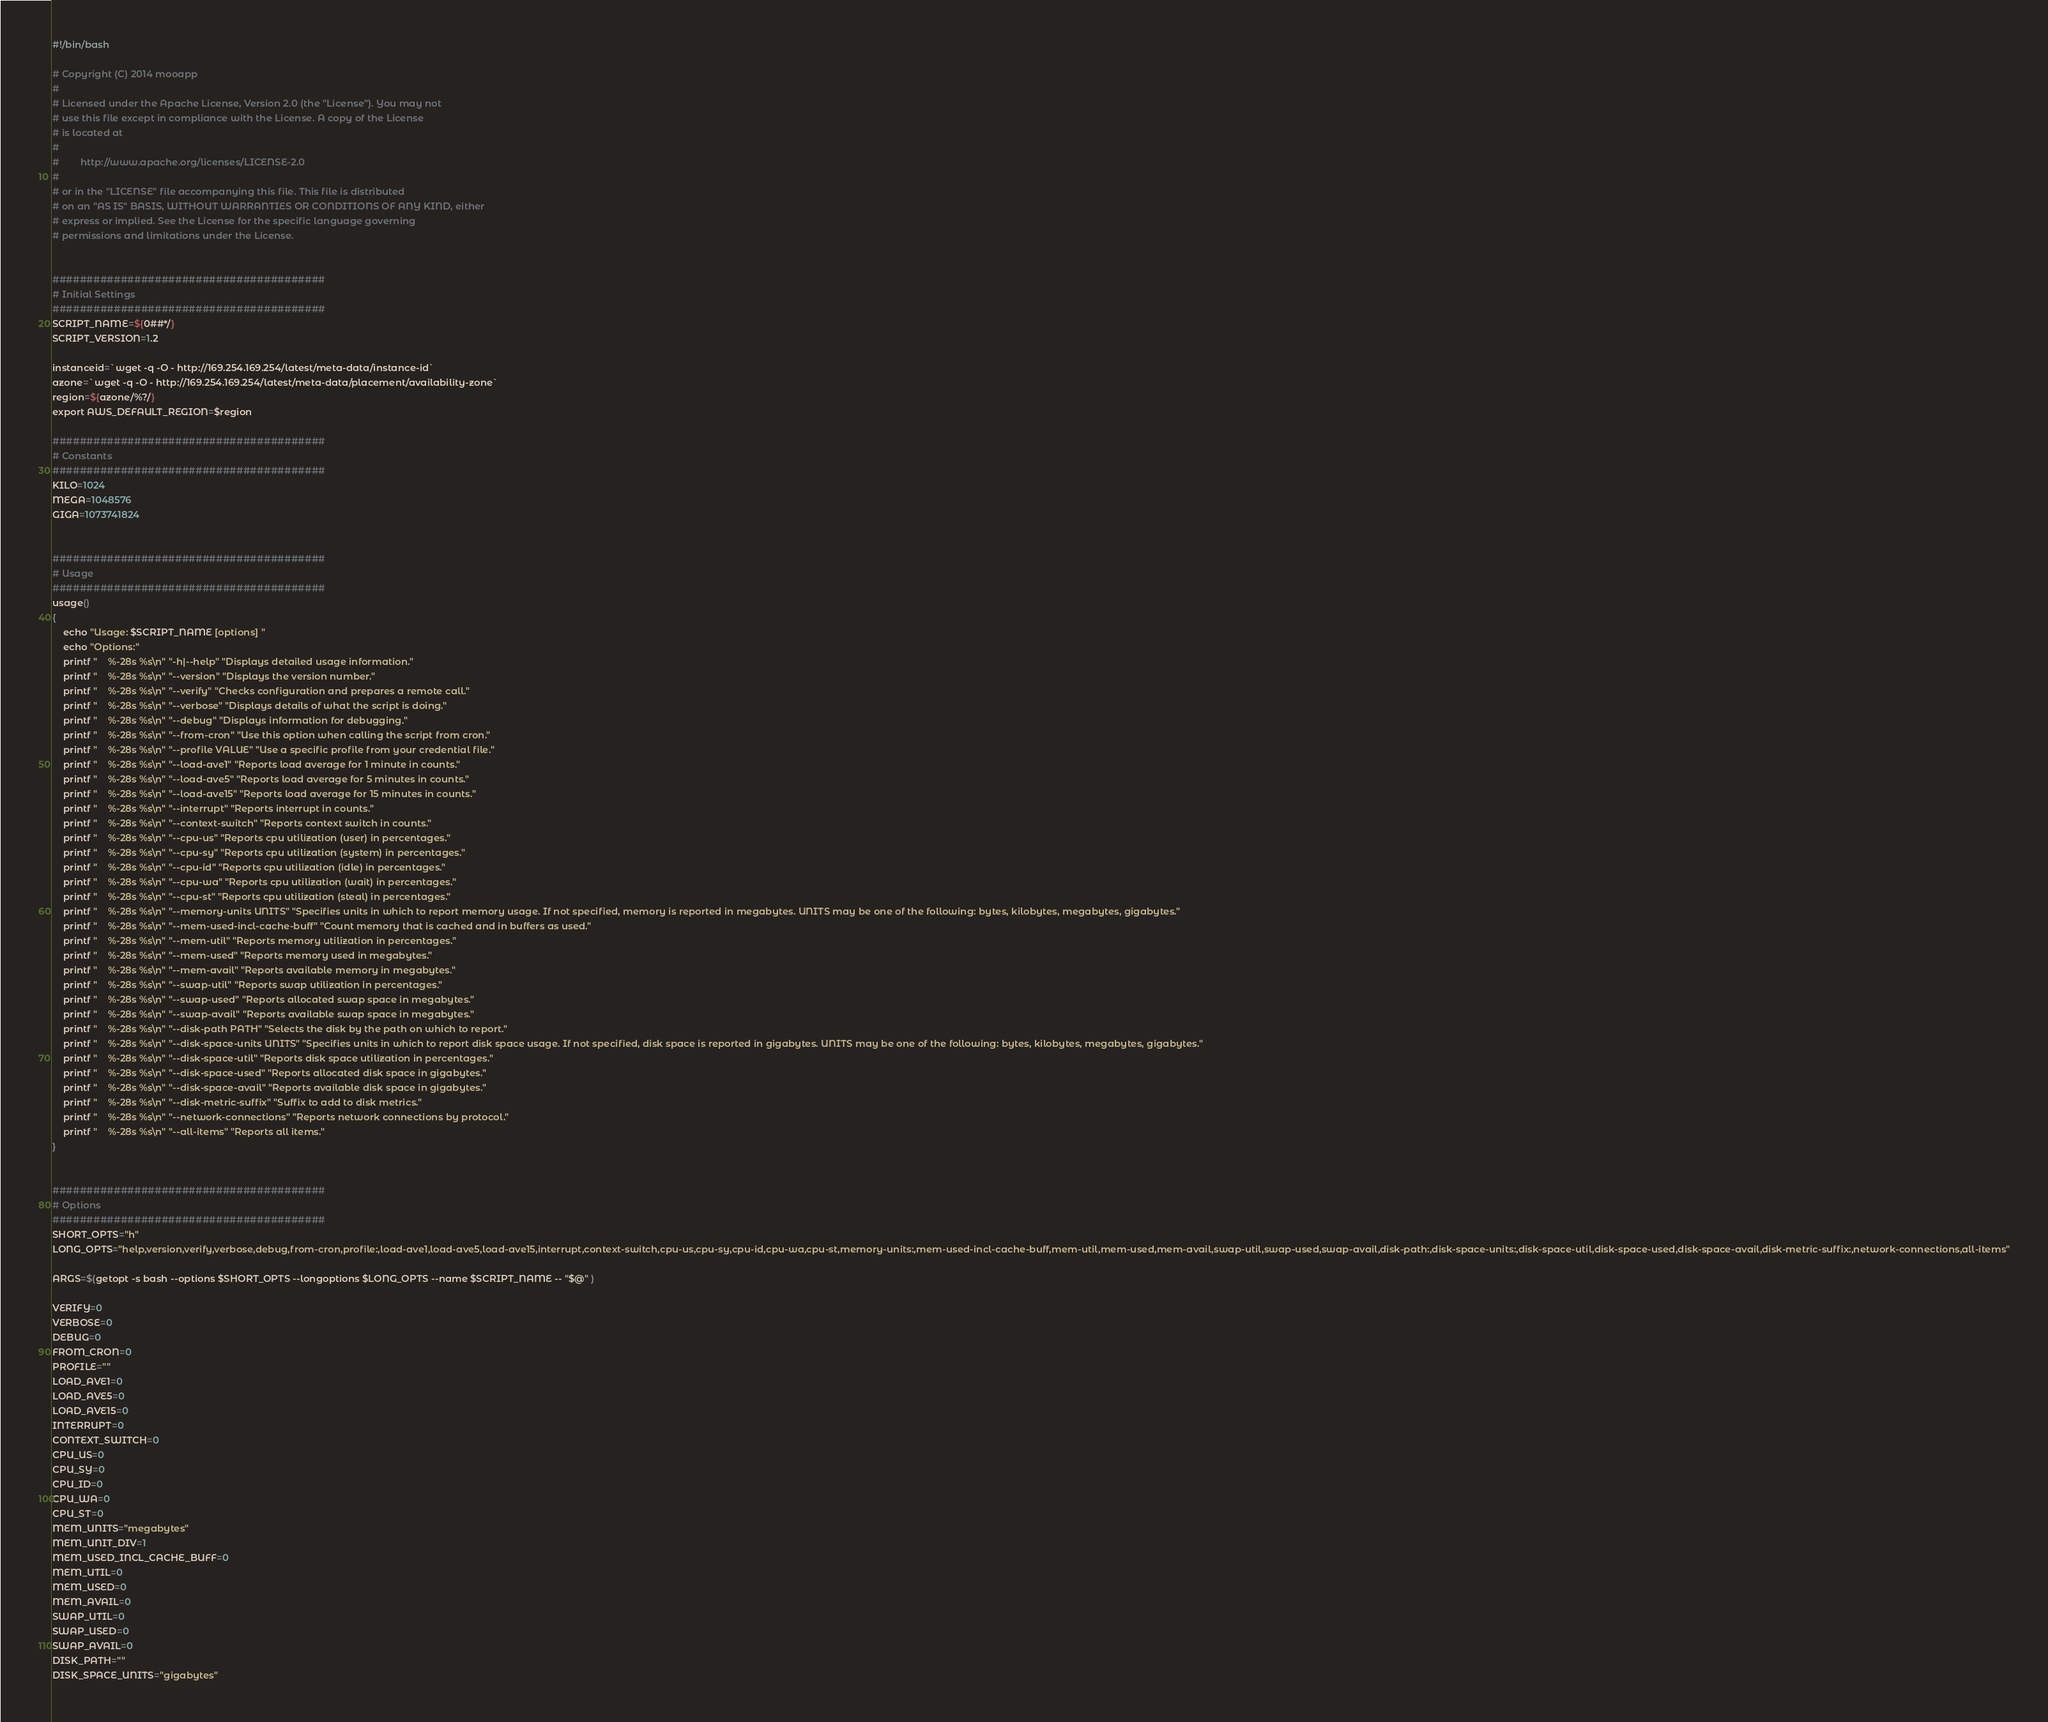Convert code to text. <code><loc_0><loc_0><loc_500><loc_500><_Bash_>#!/bin/bash

# Copyright (C) 2014 mooapp
#
# Licensed under the Apache License, Version 2.0 (the "License"). You may not
# use this file except in compliance with the License. A copy of the License
# is located at
#
#        http://www.apache.org/licenses/LICENSE-2.0
#
# or in the "LICENSE" file accompanying this file. This file is distributed
# on an "AS IS" BASIS, WITHOUT WARRANTIES OR CONDITIONS OF ANY KIND, either
# express or implied. See the License for the specific language governing
# permissions and limitations under the License.


########################################
# Initial Settings
########################################
SCRIPT_NAME=${0##*/}
SCRIPT_VERSION=1.2

instanceid=`wget -q -O - http://169.254.169.254/latest/meta-data/instance-id`
azone=`wget -q -O - http://169.254.169.254/latest/meta-data/placement/availability-zone`
region=${azone/%?/}
export AWS_DEFAULT_REGION=$region

########################################
# Constants
########################################
KILO=1024
MEGA=1048576
GIGA=1073741824


########################################
# Usage
########################################
usage()
{
    echo "Usage: $SCRIPT_NAME [options] "
    echo "Options:"
    printf "    %-28s %s\n" "-h|--help" "Displays detailed usage information."
    printf "    %-28s %s\n" "--version" "Displays the version number."
    printf "    %-28s %s\n" "--verify" "Checks configuration and prepares a remote call."
    printf "    %-28s %s\n" "--verbose" "Displays details of what the script is doing."
    printf "    %-28s %s\n" "--debug" "Displays information for debugging."
    printf "    %-28s %s\n" "--from-cron" "Use this option when calling the script from cron."
    printf "    %-28s %s\n" "--profile VALUE" "Use a specific profile from your credential file."
    printf "    %-28s %s\n" "--load-ave1" "Reports load average for 1 minute in counts."
    printf "    %-28s %s\n" "--load-ave5" "Reports load average for 5 minutes in counts."
    printf "    %-28s %s\n" "--load-ave15" "Reports load average for 15 minutes in counts."
    printf "    %-28s %s\n" "--interrupt" "Reports interrupt in counts."
    printf "    %-28s %s\n" "--context-switch" "Reports context switch in counts."
    printf "    %-28s %s\n" "--cpu-us" "Reports cpu utilization (user) in percentages."
    printf "    %-28s %s\n" "--cpu-sy" "Reports cpu utilization (system) in percentages."
    printf "    %-28s %s\n" "--cpu-id" "Reports cpu utilization (idle) in percentages."
    printf "    %-28s %s\n" "--cpu-wa" "Reports cpu utilization (wait) in percentages."
    printf "    %-28s %s\n" "--cpu-st" "Reports cpu utilization (steal) in percentages."
    printf "    %-28s %s\n" "--memory-units UNITS" "Specifies units in which to report memory usage. If not specified, memory is reported in megabytes. UNITS may be one of the following: bytes, kilobytes, megabytes, gigabytes."
    printf "    %-28s %s\n" "--mem-used-incl-cache-buff" "Count memory that is cached and in buffers as used."
    printf "    %-28s %s\n" "--mem-util" "Reports memory utilization in percentages."
    printf "    %-28s %s\n" "--mem-used" "Reports memory used in megabytes."
    printf "    %-28s %s\n" "--mem-avail" "Reports available memory in megabytes."
    printf "    %-28s %s\n" "--swap-util" "Reports swap utilization in percentages."
    printf "    %-28s %s\n" "--swap-used" "Reports allocated swap space in megabytes."
    printf "    %-28s %s\n" "--swap-avail" "Reports available swap space in megabytes."
    printf "    %-28s %s\n" "--disk-path PATH" "Selects the disk by the path on which to report."
    printf "    %-28s %s\n" "--disk-space-units UNITS" "Specifies units in which to report disk space usage. If not specified, disk space is reported in gigabytes. UNITS may be one of the following: bytes, kilobytes, megabytes, gigabytes."
    printf "    %-28s %s\n" "--disk-space-util" "Reports disk space utilization in percentages."
    printf "    %-28s %s\n" "--disk-space-used" "Reports allocated disk space in gigabytes."
    printf "    %-28s %s\n" "--disk-space-avail" "Reports available disk space in gigabytes."
    printf "    %-28s %s\n" "--disk-metric-suffix" "Suffix to add to disk metrics."
    printf "    %-28s %s\n" "--network-connections" "Reports network connections by protocol."
    printf "    %-28s %s\n" "--all-items" "Reports all items."
}


########################################
# Options
########################################
SHORT_OPTS="h"
LONG_OPTS="help,version,verify,verbose,debug,from-cron,profile:,load-ave1,load-ave5,load-ave15,interrupt,context-switch,cpu-us,cpu-sy,cpu-id,cpu-wa,cpu-st,memory-units:,mem-used-incl-cache-buff,mem-util,mem-used,mem-avail,swap-util,swap-used,swap-avail,disk-path:,disk-space-units:,disk-space-util,disk-space-used,disk-space-avail,disk-metric-suffix:,network-connections,all-items"

ARGS=$(getopt -s bash --options $SHORT_OPTS --longoptions $LONG_OPTS --name $SCRIPT_NAME -- "$@" )

VERIFY=0
VERBOSE=0
DEBUG=0
FROM_CRON=0
PROFILE=""
LOAD_AVE1=0
LOAD_AVE5=0
LOAD_AVE15=0
INTERRUPT=0
CONTEXT_SWITCH=0
CPU_US=0
CPU_SY=0
CPU_ID=0
CPU_WA=0
CPU_ST=0
MEM_UNITS="megabytes"
MEM_UNIT_DIV=1
MEM_USED_INCL_CACHE_BUFF=0
MEM_UTIL=0
MEM_USED=0
MEM_AVAIL=0
SWAP_UTIL=0
SWAP_USED=0
SWAP_AVAIL=0
DISK_PATH=""
DISK_SPACE_UNITS="gigabytes"</code> 